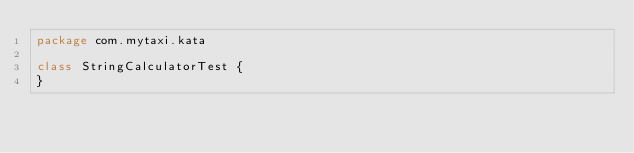Convert code to text. <code><loc_0><loc_0><loc_500><loc_500><_Kotlin_>package com.mytaxi.kata

class StringCalculatorTest {
}

</code> 